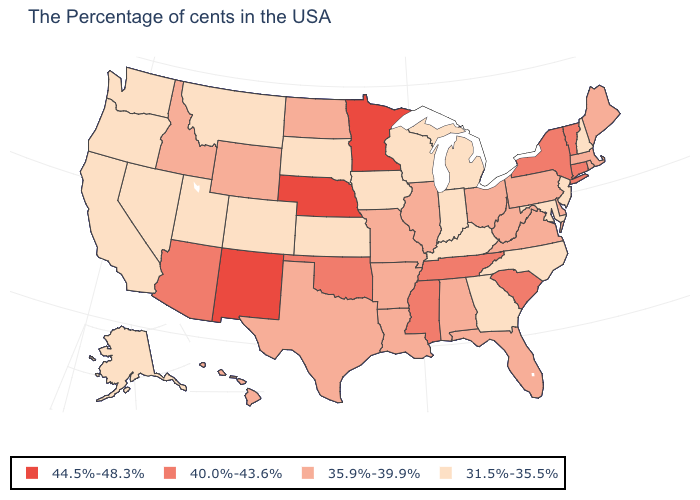What is the lowest value in states that border Alabama?
Quick response, please. 31.5%-35.5%. What is the value of Maine?
Answer briefly. 35.9%-39.9%. Which states hav the highest value in the West?
Give a very brief answer. New Mexico. What is the value of Alabama?
Concise answer only. 35.9%-39.9%. Does Rhode Island have the highest value in the USA?
Write a very short answer. No. Does Nebraska have the same value as New Mexico?
Be succinct. Yes. Name the states that have a value in the range 35.9%-39.9%?
Be succinct. Maine, Massachusetts, Rhode Island, Delaware, Pennsylvania, Virginia, West Virginia, Ohio, Florida, Alabama, Illinois, Louisiana, Missouri, Arkansas, Texas, North Dakota, Wyoming, Idaho, Hawaii. Does Kansas have a lower value than Indiana?
Quick response, please. No. What is the value of Wyoming?
Short answer required. 35.9%-39.9%. Among the states that border Rhode Island , which have the lowest value?
Write a very short answer. Massachusetts. What is the highest value in the USA?
Keep it brief. 44.5%-48.3%. Which states have the highest value in the USA?
Write a very short answer. Minnesota, Nebraska, New Mexico. What is the highest value in the MidWest ?
Answer briefly. 44.5%-48.3%. Does Kentucky have the highest value in the South?
Be succinct. No. Name the states that have a value in the range 40.0%-43.6%?
Write a very short answer. Vermont, Connecticut, New York, South Carolina, Tennessee, Mississippi, Oklahoma, Arizona. 